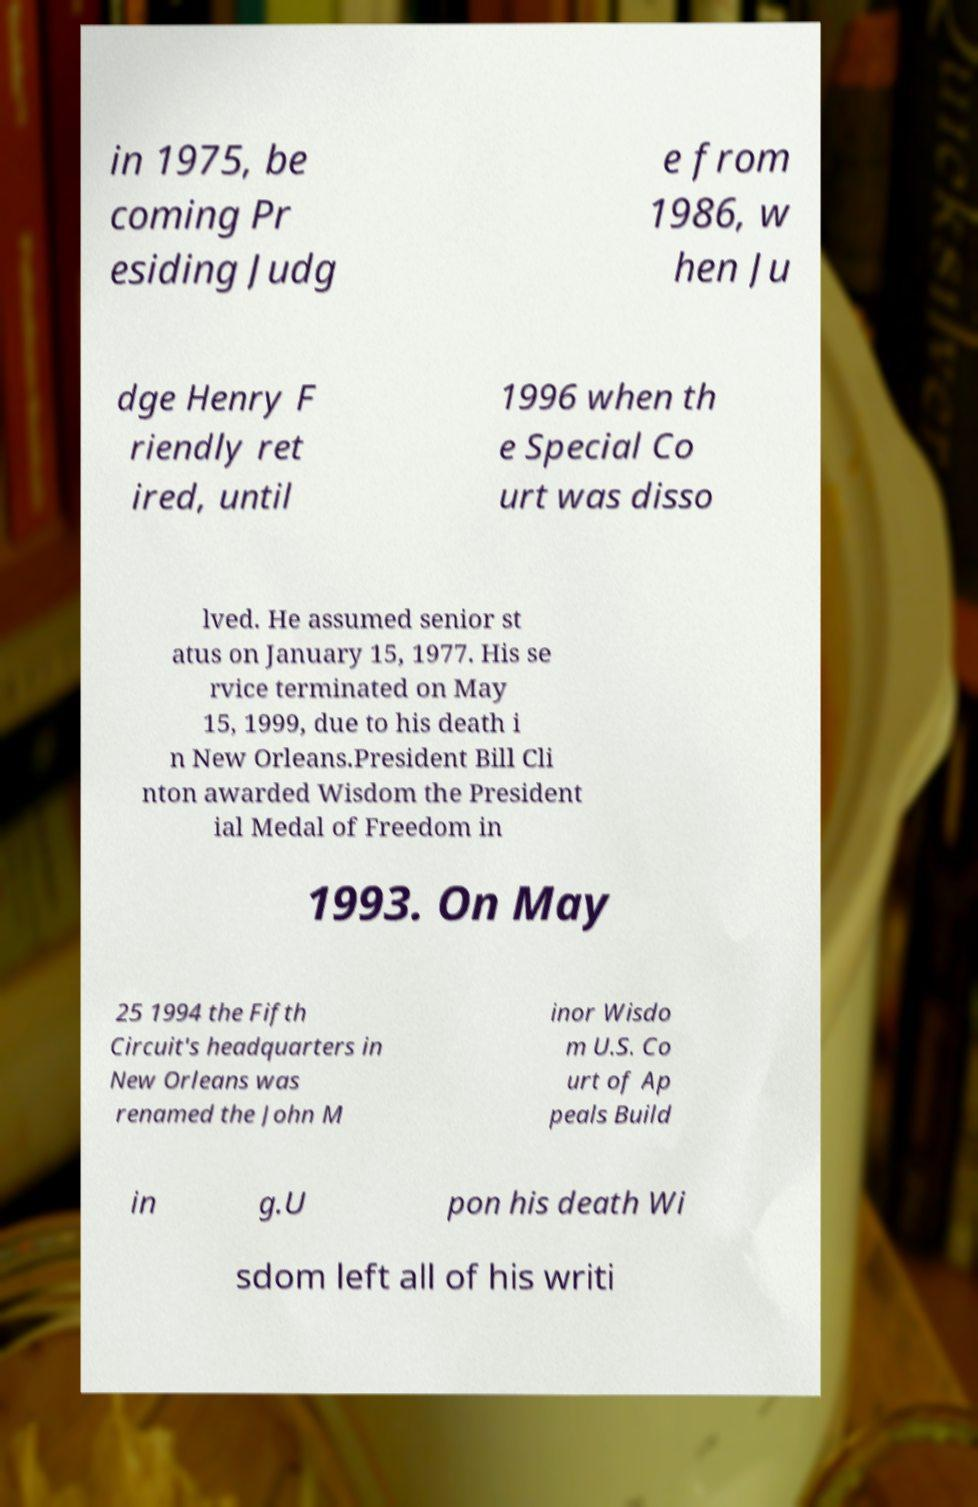For documentation purposes, I need the text within this image transcribed. Could you provide that? in 1975, be coming Pr esiding Judg e from 1986, w hen Ju dge Henry F riendly ret ired, until 1996 when th e Special Co urt was disso lved. He assumed senior st atus on January 15, 1977. His se rvice terminated on May 15, 1999, due to his death i n New Orleans.President Bill Cli nton awarded Wisdom the President ial Medal of Freedom in 1993. On May 25 1994 the Fifth Circuit's headquarters in New Orleans was renamed the John M inor Wisdo m U.S. Co urt of Ap peals Build in g.U pon his death Wi sdom left all of his writi 